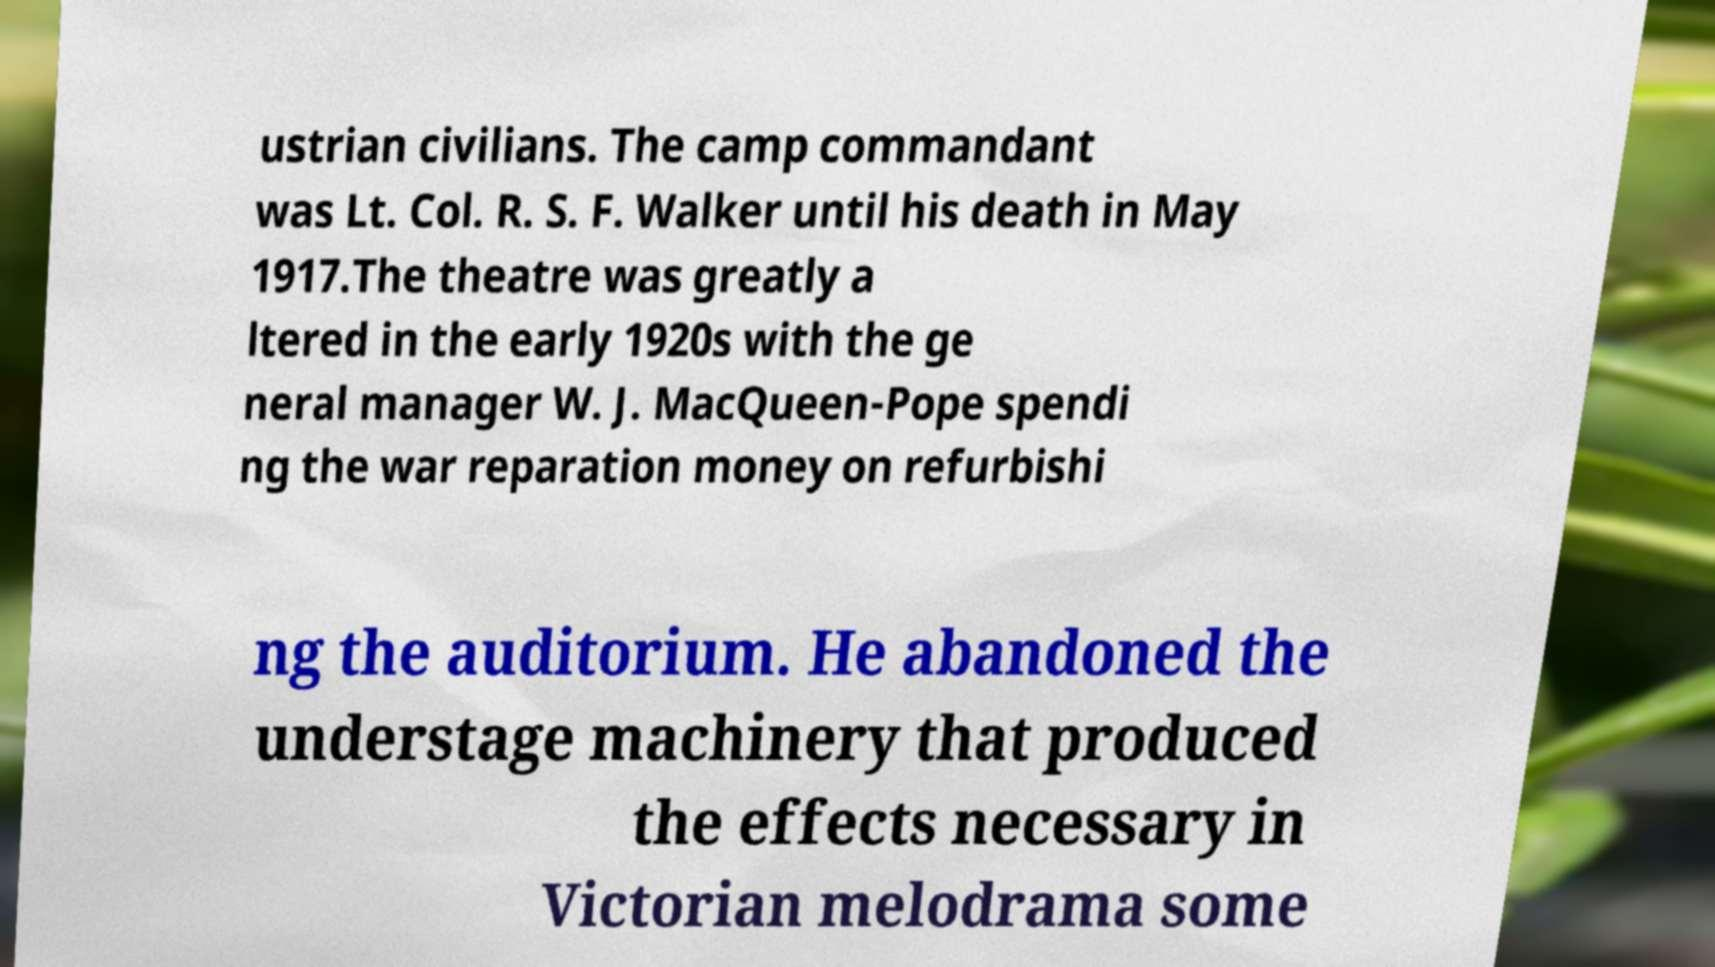Can you accurately transcribe the text from the provided image for me? ustrian civilians. The camp commandant was Lt. Col. R. S. F. Walker until his death in May 1917.The theatre was greatly a ltered in the early 1920s with the ge neral manager W. J. MacQueen-Pope spendi ng the war reparation money on refurbishi ng the auditorium. He abandoned the understage machinery that produced the effects necessary in Victorian melodrama some 